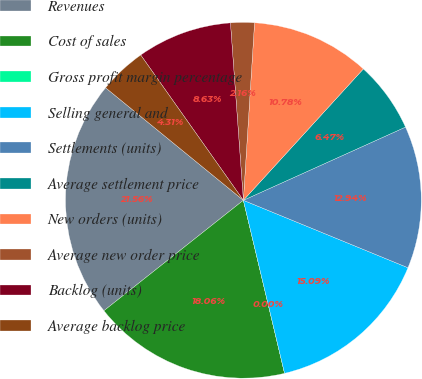<chart> <loc_0><loc_0><loc_500><loc_500><pie_chart><fcel>Revenues<fcel>Cost of sales<fcel>Gross profit margin percentage<fcel>Selling general and<fcel>Settlements (units)<fcel>Average settlement price<fcel>New orders (units)<fcel>Average new order price<fcel>Backlog (units)<fcel>Average backlog price<nl><fcel>21.56%<fcel>18.06%<fcel>0.0%<fcel>15.09%<fcel>12.94%<fcel>6.47%<fcel>10.78%<fcel>2.16%<fcel>8.63%<fcel>4.31%<nl></chart> 